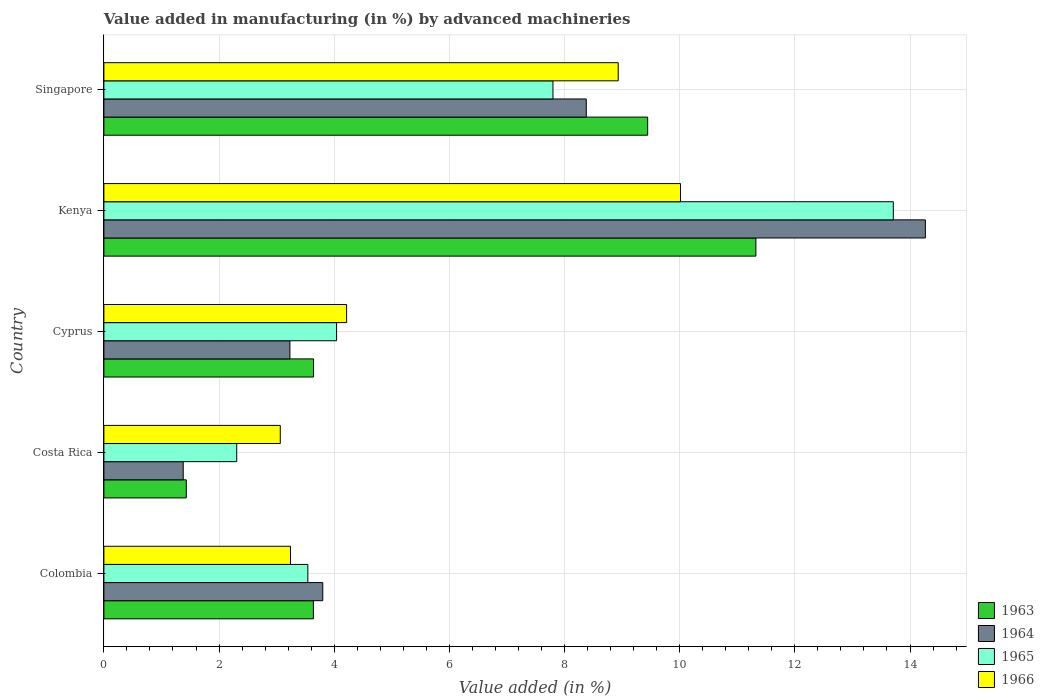How many groups of bars are there?
Ensure brevity in your answer.  5. Are the number of bars per tick equal to the number of legend labels?
Provide a succinct answer. Yes. Are the number of bars on each tick of the Y-axis equal?
Keep it short and to the point. Yes. How many bars are there on the 5th tick from the bottom?
Your response must be concise. 4. What is the label of the 3rd group of bars from the top?
Keep it short and to the point. Cyprus. In how many cases, is the number of bars for a given country not equal to the number of legend labels?
Provide a short and direct response. 0. What is the percentage of value added in manufacturing by advanced machineries in 1966 in Colombia?
Your answer should be very brief. 3.24. Across all countries, what is the maximum percentage of value added in manufacturing by advanced machineries in 1964?
Provide a succinct answer. 14.27. Across all countries, what is the minimum percentage of value added in manufacturing by advanced machineries in 1963?
Keep it short and to the point. 1.43. In which country was the percentage of value added in manufacturing by advanced machineries in 1964 maximum?
Provide a short and direct response. Kenya. What is the total percentage of value added in manufacturing by advanced machineries in 1965 in the graph?
Provide a succinct answer. 31.4. What is the difference between the percentage of value added in manufacturing by advanced machineries in 1965 in Colombia and that in Kenya?
Provide a short and direct response. -10.17. What is the difference between the percentage of value added in manufacturing by advanced machineries in 1965 in Cyprus and the percentage of value added in manufacturing by advanced machineries in 1966 in Costa Rica?
Your answer should be very brief. 0.98. What is the average percentage of value added in manufacturing by advanced machineries in 1963 per country?
Ensure brevity in your answer.  5.9. What is the difference between the percentage of value added in manufacturing by advanced machineries in 1966 and percentage of value added in manufacturing by advanced machineries in 1964 in Cyprus?
Ensure brevity in your answer.  0.98. In how many countries, is the percentage of value added in manufacturing by advanced machineries in 1965 greater than 10.4 %?
Ensure brevity in your answer.  1. What is the ratio of the percentage of value added in manufacturing by advanced machineries in 1963 in Costa Rica to that in Cyprus?
Keep it short and to the point. 0.39. Is the percentage of value added in manufacturing by advanced machineries in 1965 in Costa Rica less than that in Cyprus?
Provide a succinct answer. Yes. Is the difference between the percentage of value added in manufacturing by advanced machineries in 1966 in Cyprus and Kenya greater than the difference between the percentage of value added in manufacturing by advanced machineries in 1964 in Cyprus and Kenya?
Ensure brevity in your answer.  Yes. What is the difference between the highest and the second highest percentage of value added in manufacturing by advanced machineries in 1963?
Offer a very short reply. 1.88. What is the difference between the highest and the lowest percentage of value added in manufacturing by advanced machineries in 1963?
Ensure brevity in your answer.  9.89. In how many countries, is the percentage of value added in manufacturing by advanced machineries in 1964 greater than the average percentage of value added in manufacturing by advanced machineries in 1964 taken over all countries?
Make the answer very short. 2. What does the 1st bar from the top in Colombia represents?
Keep it short and to the point. 1966. What does the 1st bar from the bottom in Costa Rica represents?
Your answer should be very brief. 1963. Is it the case that in every country, the sum of the percentage of value added in manufacturing by advanced machineries in 1963 and percentage of value added in manufacturing by advanced machineries in 1964 is greater than the percentage of value added in manufacturing by advanced machineries in 1966?
Provide a short and direct response. No. How many bars are there?
Offer a very short reply. 20. Are the values on the major ticks of X-axis written in scientific E-notation?
Provide a short and direct response. No. Does the graph contain grids?
Offer a terse response. Yes. What is the title of the graph?
Provide a short and direct response. Value added in manufacturing (in %) by advanced machineries. What is the label or title of the X-axis?
Your answer should be very brief. Value added (in %). What is the label or title of the Y-axis?
Offer a terse response. Country. What is the Value added (in %) of 1963 in Colombia?
Provide a short and direct response. 3.64. What is the Value added (in %) of 1964 in Colombia?
Make the answer very short. 3.8. What is the Value added (in %) of 1965 in Colombia?
Your answer should be compact. 3.54. What is the Value added (in %) of 1966 in Colombia?
Offer a terse response. 3.24. What is the Value added (in %) in 1963 in Costa Rica?
Your answer should be very brief. 1.43. What is the Value added (in %) in 1964 in Costa Rica?
Offer a terse response. 1.38. What is the Value added (in %) in 1965 in Costa Rica?
Provide a short and direct response. 2.31. What is the Value added (in %) of 1966 in Costa Rica?
Provide a short and direct response. 3.06. What is the Value added (in %) of 1963 in Cyprus?
Offer a terse response. 3.64. What is the Value added (in %) of 1964 in Cyprus?
Offer a very short reply. 3.23. What is the Value added (in %) of 1965 in Cyprus?
Offer a terse response. 4.04. What is the Value added (in %) in 1966 in Cyprus?
Provide a short and direct response. 4.22. What is the Value added (in %) of 1963 in Kenya?
Offer a very short reply. 11.32. What is the Value added (in %) in 1964 in Kenya?
Offer a terse response. 14.27. What is the Value added (in %) of 1965 in Kenya?
Your response must be concise. 13.71. What is the Value added (in %) in 1966 in Kenya?
Ensure brevity in your answer.  10.01. What is the Value added (in %) in 1963 in Singapore?
Offer a terse response. 9.44. What is the Value added (in %) in 1964 in Singapore?
Your response must be concise. 8.38. What is the Value added (in %) in 1965 in Singapore?
Give a very brief answer. 7.8. What is the Value added (in %) in 1966 in Singapore?
Make the answer very short. 8.93. Across all countries, what is the maximum Value added (in %) of 1963?
Provide a succinct answer. 11.32. Across all countries, what is the maximum Value added (in %) of 1964?
Keep it short and to the point. 14.27. Across all countries, what is the maximum Value added (in %) of 1965?
Your response must be concise. 13.71. Across all countries, what is the maximum Value added (in %) in 1966?
Offer a very short reply. 10.01. Across all countries, what is the minimum Value added (in %) in 1963?
Make the answer very short. 1.43. Across all countries, what is the minimum Value added (in %) of 1964?
Offer a terse response. 1.38. Across all countries, what is the minimum Value added (in %) in 1965?
Provide a short and direct response. 2.31. Across all countries, what is the minimum Value added (in %) in 1966?
Make the answer very short. 3.06. What is the total Value added (in %) of 1963 in the graph?
Provide a succinct answer. 29.48. What is the total Value added (in %) of 1964 in the graph?
Ensure brevity in your answer.  31.05. What is the total Value added (in %) of 1965 in the graph?
Make the answer very short. 31.4. What is the total Value added (in %) in 1966 in the graph?
Your answer should be very brief. 29.47. What is the difference between the Value added (in %) in 1963 in Colombia and that in Costa Rica?
Offer a terse response. 2.21. What is the difference between the Value added (in %) in 1964 in Colombia and that in Costa Rica?
Make the answer very short. 2.42. What is the difference between the Value added (in %) of 1965 in Colombia and that in Costa Rica?
Your answer should be compact. 1.24. What is the difference between the Value added (in %) of 1966 in Colombia and that in Costa Rica?
Make the answer very short. 0.18. What is the difference between the Value added (in %) in 1963 in Colombia and that in Cyprus?
Your answer should be very brief. -0. What is the difference between the Value added (in %) in 1964 in Colombia and that in Cyprus?
Keep it short and to the point. 0.57. What is the difference between the Value added (in %) in 1965 in Colombia and that in Cyprus?
Your answer should be very brief. -0.5. What is the difference between the Value added (in %) of 1966 in Colombia and that in Cyprus?
Provide a succinct answer. -0.97. What is the difference between the Value added (in %) in 1963 in Colombia and that in Kenya?
Offer a very short reply. -7.69. What is the difference between the Value added (in %) of 1964 in Colombia and that in Kenya?
Your answer should be very brief. -10.47. What is the difference between the Value added (in %) of 1965 in Colombia and that in Kenya?
Your answer should be very brief. -10.17. What is the difference between the Value added (in %) in 1966 in Colombia and that in Kenya?
Keep it short and to the point. -6.77. What is the difference between the Value added (in %) in 1963 in Colombia and that in Singapore?
Your answer should be very brief. -5.81. What is the difference between the Value added (in %) of 1964 in Colombia and that in Singapore?
Make the answer very short. -4.58. What is the difference between the Value added (in %) in 1965 in Colombia and that in Singapore?
Provide a short and direct response. -4.26. What is the difference between the Value added (in %) of 1966 in Colombia and that in Singapore?
Provide a short and direct response. -5.69. What is the difference between the Value added (in %) of 1963 in Costa Rica and that in Cyprus?
Your response must be concise. -2.21. What is the difference between the Value added (in %) of 1964 in Costa Rica and that in Cyprus?
Your response must be concise. -1.85. What is the difference between the Value added (in %) of 1965 in Costa Rica and that in Cyprus?
Ensure brevity in your answer.  -1.73. What is the difference between the Value added (in %) in 1966 in Costa Rica and that in Cyprus?
Your answer should be compact. -1.15. What is the difference between the Value added (in %) of 1963 in Costa Rica and that in Kenya?
Ensure brevity in your answer.  -9.89. What is the difference between the Value added (in %) in 1964 in Costa Rica and that in Kenya?
Keep it short and to the point. -12.89. What is the difference between the Value added (in %) of 1965 in Costa Rica and that in Kenya?
Make the answer very short. -11.4. What is the difference between the Value added (in %) in 1966 in Costa Rica and that in Kenya?
Make the answer very short. -6.95. What is the difference between the Value added (in %) in 1963 in Costa Rica and that in Singapore?
Offer a very short reply. -8.01. What is the difference between the Value added (in %) of 1964 in Costa Rica and that in Singapore?
Provide a succinct answer. -7. What is the difference between the Value added (in %) in 1965 in Costa Rica and that in Singapore?
Offer a very short reply. -5.49. What is the difference between the Value added (in %) in 1966 in Costa Rica and that in Singapore?
Provide a succinct answer. -5.87. What is the difference between the Value added (in %) of 1963 in Cyprus and that in Kenya?
Provide a succinct answer. -7.68. What is the difference between the Value added (in %) in 1964 in Cyprus and that in Kenya?
Your answer should be very brief. -11.04. What is the difference between the Value added (in %) of 1965 in Cyprus and that in Kenya?
Keep it short and to the point. -9.67. What is the difference between the Value added (in %) of 1966 in Cyprus and that in Kenya?
Ensure brevity in your answer.  -5.8. What is the difference between the Value added (in %) in 1963 in Cyprus and that in Singapore?
Your answer should be very brief. -5.8. What is the difference between the Value added (in %) of 1964 in Cyprus and that in Singapore?
Offer a terse response. -5.15. What is the difference between the Value added (in %) of 1965 in Cyprus and that in Singapore?
Your response must be concise. -3.76. What is the difference between the Value added (in %) in 1966 in Cyprus and that in Singapore?
Provide a succinct answer. -4.72. What is the difference between the Value added (in %) of 1963 in Kenya and that in Singapore?
Your answer should be very brief. 1.88. What is the difference between the Value added (in %) in 1964 in Kenya and that in Singapore?
Your response must be concise. 5.89. What is the difference between the Value added (in %) in 1965 in Kenya and that in Singapore?
Your answer should be very brief. 5.91. What is the difference between the Value added (in %) in 1966 in Kenya and that in Singapore?
Give a very brief answer. 1.08. What is the difference between the Value added (in %) in 1963 in Colombia and the Value added (in %) in 1964 in Costa Rica?
Your answer should be compact. 2.26. What is the difference between the Value added (in %) in 1963 in Colombia and the Value added (in %) in 1965 in Costa Rica?
Your answer should be very brief. 1.33. What is the difference between the Value added (in %) in 1963 in Colombia and the Value added (in %) in 1966 in Costa Rica?
Make the answer very short. 0.57. What is the difference between the Value added (in %) of 1964 in Colombia and the Value added (in %) of 1965 in Costa Rica?
Give a very brief answer. 1.49. What is the difference between the Value added (in %) in 1964 in Colombia and the Value added (in %) in 1966 in Costa Rica?
Offer a very short reply. 0.74. What is the difference between the Value added (in %) in 1965 in Colombia and the Value added (in %) in 1966 in Costa Rica?
Keep it short and to the point. 0.48. What is the difference between the Value added (in %) of 1963 in Colombia and the Value added (in %) of 1964 in Cyprus?
Offer a very short reply. 0.41. What is the difference between the Value added (in %) in 1963 in Colombia and the Value added (in %) in 1965 in Cyprus?
Your answer should be compact. -0.4. What is the difference between the Value added (in %) of 1963 in Colombia and the Value added (in %) of 1966 in Cyprus?
Give a very brief answer. -0.58. What is the difference between the Value added (in %) in 1964 in Colombia and the Value added (in %) in 1965 in Cyprus?
Give a very brief answer. -0.24. What is the difference between the Value added (in %) in 1964 in Colombia and the Value added (in %) in 1966 in Cyprus?
Make the answer very short. -0.41. What is the difference between the Value added (in %) of 1965 in Colombia and the Value added (in %) of 1966 in Cyprus?
Ensure brevity in your answer.  -0.67. What is the difference between the Value added (in %) in 1963 in Colombia and the Value added (in %) in 1964 in Kenya?
Provide a short and direct response. -10.63. What is the difference between the Value added (in %) of 1963 in Colombia and the Value added (in %) of 1965 in Kenya?
Offer a terse response. -10.07. What is the difference between the Value added (in %) in 1963 in Colombia and the Value added (in %) in 1966 in Kenya?
Ensure brevity in your answer.  -6.38. What is the difference between the Value added (in %) of 1964 in Colombia and the Value added (in %) of 1965 in Kenya?
Your response must be concise. -9.91. What is the difference between the Value added (in %) of 1964 in Colombia and the Value added (in %) of 1966 in Kenya?
Offer a terse response. -6.21. What is the difference between the Value added (in %) in 1965 in Colombia and the Value added (in %) in 1966 in Kenya?
Make the answer very short. -6.47. What is the difference between the Value added (in %) of 1963 in Colombia and the Value added (in %) of 1964 in Singapore?
Offer a very short reply. -4.74. What is the difference between the Value added (in %) of 1963 in Colombia and the Value added (in %) of 1965 in Singapore?
Keep it short and to the point. -4.16. What is the difference between the Value added (in %) in 1963 in Colombia and the Value added (in %) in 1966 in Singapore?
Offer a very short reply. -5.29. What is the difference between the Value added (in %) of 1964 in Colombia and the Value added (in %) of 1965 in Singapore?
Your answer should be compact. -4. What is the difference between the Value added (in %) in 1964 in Colombia and the Value added (in %) in 1966 in Singapore?
Your answer should be compact. -5.13. What is the difference between the Value added (in %) in 1965 in Colombia and the Value added (in %) in 1966 in Singapore?
Make the answer very short. -5.39. What is the difference between the Value added (in %) of 1963 in Costa Rica and the Value added (in %) of 1964 in Cyprus?
Provide a short and direct response. -1.8. What is the difference between the Value added (in %) in 1963 in Costa Rica and the Value added (in %) in 1965 in Cyprus?
Provide a succinct answer. -2.61. What is the difference between the Value added (in %) of 1963 in Costa Rica and the Value added (in %) of 1966 in Cyprus?
Keep it short and to the point. -2.78. What is the difference between the Value added (in %) in 1964 in Costa Rica and the Value added (in %) in 1965 in Cyprus?
Ensure brevity in your answer.  -2.66. What is the difference between the Value added (in %) of 1964 in Costa Rica and the Value added (in %) of 1966 in Cyprus?
Offer a terse response. -2.84. What is the difference between the Value added (in %) of 1965 in Costa Rica and the Value added (in %) of 1966 in Cyprus?
Offer a terse response. -1.91. What is the difference between the Value added (in %) in 1963 in Costa Rica and the Value added (in %) in 1964 in Kenya?
Your answer should be very brief. -12.84. What is the difference between the Value added (in %) of 1963 in Costa Rica and the Value added (in %) of 1965 in Kenya?
Provide a short and direct response. -12.28. What is the difference between the Value added (in %) in 1963 in Costa Rica and the Value added (in %) in 1966 in Kenya?
Provide a short and direct response. -8.58. What is the difference between the Value added (in %) in 1964 in Costa Rica and the Value added (in %) in 1965 in Kenya?
Your answer should be compact. -12.33. What is the difference between the Value added (in %) in 1964 in Costa Rica and the Value added (in %) in 1966 in Kenya?
Provide a short and direct response. -8.64. What is the difference between the Value added (in %) in 1965 in Costa Rica and the Value added (in %) in 1966 in Kenya?
Your answer should be compact. -7.71. What is the difference between the Value added (in %) in 1963 in Costa Rica and the Value added (in %) in 1964 in Singapore?
Provide a succinct answer. -6.95. What is the difference between the Value added (in %) in 1963 in Costa Rica and the Value added (in %) in 1965 in Singapore?
Give a very brief answer. -6.37. What is the difference between the Value added (in %) in 1963 in Costa Rica and the Value added (in %) in 1966 in Singapore?
Offer a terse response. -7.5. What is the difference between the Value added (in %) of 1964 in Costa Rica and the Value added (in %) of 1965 in Singapore?
Ensure brevity in your answer.  -6.42. What is the difference between the Value added (in %) in 1964 in Costa Rica and the Value added (in %) in 1966 in Singapore?
Keep it short and to the point. -7.55. What is the difference between the Value added (in %) in 1965 in Costa Rica and the Value added (in %) in 1966 in Singapore?
Provide a short and direct response. -6.63. What is the difference between the Value added (in %) of 1963 in Cyprus and the Value added (in %) of 1964 in Kenya?
Provide a short and direct response. -10.63. What is the difference between the Value added (in %) of 1963 in Cyprus and the Value added (in %) of 1965 in Kenya?
Offer a very short reply. -10.07. What is the difference between the Value added (in %) of 1963 in Cyprus and the Value added (in %) of 1966 in Kenya?
Your response must be concise. -6.37. What is the difference between the Value added (in %) of 1964 in Cyprus and the Value added (in %) of 1965 in Kenya?
Your answer should be very brief. -10.48. What is the difference between the Value added (in %) of 1964 in Cyprus and the Value added (in %) of 1966 in Kenya?
Ensure brevity in your answer.  -6.78. What is the difference between the Value added (in %) in 1965 in Cyprus and the Value added (in %) in 1966 in Kenya?
Your answer should be compact. -5.97. What is the difference between the Value added (in %) of 1963 in Cyprus and the Value added (in %) of 1964 in Singapore?
Provide a short and direct response. -4.74. What is the difference between the Value added (in %) in 1963 in Cyprus and the Value added (in %) in 1965 in Singapore?
Provide a succinct answer. -4.16. What is the difference between the Value added (in %) in 1963 in Cyprus and the Value added (in %) in 1966 in Singapore?
Your answer should be very brief. -5.29. What is the difference between the Value added (in %) of 1964 in Cyprus and the Value added (in %) of 1965 in Singapore?
Your response must be concise. -4.57. What is the difference between the Value added (in %) in 1964 in Cyprus and the Value added (in %) in 1966 in Singapore?
Provide a short and direct response. -5.7. What is the difference between the Value added (in %) in 1965 in Cyprus and the Value added (in %) in 1966 in Singapore?
Your answer should be compact. -4.89. What is the difference between the Value added (in %) in 1963 in Kenya and the Value added (in %) in 1964 in Singapore?
Give a very brief answer. 2.95. What is the difference between the Value added (in %) of 1963 in Kenya and the Value added (in %) of 1965 in Singapore?
Provide a short and direct response. 3.52. What is the difference between the Value added (in %) in 1963 in Kenya and the Value added (in %) in 1966 in Singapore?
Your response must be concise. 2.39. What is the difference between the Value added (in %) in 1964 in Kenya and the Value added (in %) in 1965 in Singapore?
Provide a short and direct response. 6.47. What is the difference between the Value added (in %) of 1964 in Kenya and the Value added (in %) of 1966 in Singapore?
Provide a succinct answer. 5.33. What is the difference between the Value added (in %) of 1965 in Kenya and the Value added (in %) of 1966 in Singapore?
Your answer should be very brief. 4.78. What is the average Value added (in %) in 1963 per country?
Offer a terse response. 5.9. What is the average Value added (in %) of 1964 per country?
Keep it short and to the point. 6.21. What is the average Value added (in %) of 1965 per country?
Offer a very short reply. 6.28. What is the average Value added (in %) of 1966 per country?
Your answer should be very brief. 5.89. What is the difference between the Value added (in %) in 1963 and Value added (in %) in 1964 in Colombia?
Make the answer very short. -0.16. What is the difference between the Value added (in %) of 1963 and Value added (in %) of 1965 in Colombia?
Make the answer very short. 0.1. What is the difference between the Value added (in %) of 1963 and Value added (in %) of 1966 in Colombia?
Offer a very short reply. 0.4. What is the difference between the Value added (in %) of 1964 and Value added (in %) of 1965 in Colombia?
Offer a very short reply. 0.26. What is the difference between the Value added (in %) in 1964 and Value added (in %) in 1966 in Colombia?
Your answer should be very brief. 0.56. What is the difference between the Value added (in %) in 1965 and Value added (in %) in 1966 in Colombia?
Provide a short and direct response. 0.3. What is the difference between the Value added (in %) of 1963 and Value added (in %) of 1964 in Costa Rica?
Offer a terse response. 0.05. What is the difference between the Value added (in %) of 1963 and Value added (in %) of 1965 in Costa Rica?
Offer a terse response. -0.88. What is the difference between the Value added (in %) in 1963 and Value added (in %) in 1966 in Costa Rica?
Your response must be concise. -1.63. What is the difference between the Value added (in %) of 1964 and Value added (in %) of 1965 in Costa Rica?
Make the answer very short. -0.93. What is the difference between the Value added (in %) of 1964 and Value added (in %) of 1966 in Costa Rica?
Make the answer very short. -1.69. What is the difference between the Value added (in %) of 1965 and Value added (in %) of 1966 in Costa Rica?
Your answer should be compact. -0.76. What is the difference between the Value added (in %) of 1963 and Value added (in %) of 1964 in Cyprus?
Your answer should be very brief. 0.41. What is the difference between the Value added (in %) in 1963 and Value added (in %) in 1965 in Cyprus?
Provide a succinct answer. -0.4. What is the difference between the Value added (in %) of 1963 and Value added (in %) of 1966 in Cyprus?
Provide a short and direct response. -0.57. What is the difference between the Value added (in %) of 1964 and Value added (in %) of 1965 in Cyprus?
Give a very brief answer. -0.81. What is the difference between the Value added (in %) of 1964 and Value added (in %) of 1966 in Cyprus?
Offer a very short reply. -0.98. What is the difference between the Value added (in %) of 1965 and Value added (in %) of 1966 in Cyprus?
Your response must be concise. -0.17. What is the difference between the Value added (in %) of 1963 and Value added (in %) of 1964 in Kenya?
Your answer should be compact. -2.94. What is the difference between the Value added (in %) in 1963 and Value added (in %) in 1965 in Kenya?
Your response must be concise. -2.39. What is the difference between the Value added (in %) of 1963 and Value added (in %) of 1966 in Kenya?
Offer a very short reply. 1.31. What is the difference between the Value added (in %) in 1964 and Value added (in %) in 1965 in Kenya?
Make the answer very short. 0.56. What is the difference between the Value added (in %) of 1964 and Value added (in %) of 1966 in Kenya?
Provide a short and direct response. 4.25. What is the difference between the Value added (in %) in 1965 and Value added (in %) in 1966 in Kenya?
Make the answer very short. 3.7. What is the difference between the Value added (in %) in 1963 and Value added (in %) in 1964 in Singapore?
Ensure brevity in your answer.  1.07. What is the difference between the Value added (in %) in 1963 and Value added (in %) in 1965 in Singapore?
Provide a short and direct response. 1.64. What is the difference between the Value added (in %) in 1963 and Value added (in %) in 1966 in Singapore?
Provide a short and direct response. 0.51. What is the difference between the Value added (in %) of 1964 and Value added (in %) of 1965 in Singapore?
Provide a succinct answer. 0.58. What is the difference between the Value added (in %) of 1964 and Value added (in %) of 1966 in Singapore?
Give a very brief answer. -0.55. What is the difference between the Value added (in %) in 1965 and Value added (in %) in 1966 in Singapore?
Offer a very short reply. -1.13. What is the ratio of the Value added (in %) in 1963 in Colombia to that in Costa Rica?
Make the answer very short. 2.54. What is the ratio of the Value added (in %) of 1964 in Colombia to that in Costa Rica?
Offer a terse response. 2.76. What is the ratio of the Value added (in %) of 1965 in Colombia to that in Costa Rica?
Ensure brevity in your answer.  1.54. What is the ratio of the Value added (in %) of 1966 in Colombia to that in Costa Rica?
Keep it short and to the point. 1.06. What is the ratio of the Value added (in %) of 1964 in Colombia to that in Cyprus?
Your answer should be very brief. 1.18. What is the ratio of the Value added (in %) in 1965 in Colombia to that in Cyprus?
Ensure brevity in your answer.  0.88. What is the ratio of the Value added (in %) in 1966 in Colombia to that in Cyprus?
Provide a short and direct response. 0.77. What is the ratio of the Value added (in %) in 1963 in Colombia to that in Kenya?
Keep it short and to the point. 0.32. What is the ratio of the Value added (in %) of 1964 in Colombia to that in Kenya?
Your response must be concise. 0.27. What is the ratio of the Value added (in %) in 1965 in Colombia to that in Kenya?
Give a very brief answer. 0.26. What is the ratio of the Value added (in %) in 1966 in Colombia to that in Kenya?
Keep it short and to the point. 0.32. What is the ratio of the Value added (in %) of 1963 in Colombia to that in Singapore?
Make the answer very short. 0.39. What is the ratio of the Value added (in %) in 1964 in Colombia to that in Singapore?
Provide a short and direct response. 0.45. What is the ratio of the Value added (in %) of 1965 in Colombia to that in Singapore?
Provide a short and direct response. 0.45. What is the ratio of the Value added (in %) in 1966 in Colombia to that in Singapore?
Provide a succinct answer. 0.36. What is the ratio of the Value added (in %) in 1963 in Costa Rica to that in Cyprus?
Give a very brief answer. 0.39. What is the ratio of the Value added (in %) in 1964 in Costa Rica to that in Cyprus?
Keep it short and to the point. 0.43. What is the ratio of the Value added (in %) of 1965 in Costa Rica to that in Cyprus?
Provide a short and direct response. 0.57. What is the ratio of the Value added (in %) in 1966 in Costa Rica to that in Cyprus?
Offer a terse response. 0.73. What is the ratio of the Value added (in %) in 1963 in Costa Rica to that in Kenya?
Your answer should be compact. 0.13. What is the ratio of the Value added (in %) in 1964 in Costa Rica to that in Kenya?
Give a very brief answer. 0.1. What is the ratio of the Value added (in %) of 1965 in Costa Rica to that in Kenya?
Ensure brevity in your answer.  0.17. What is the ratio of the Value added (in %) of 1966 in Costa Rica to that in Kenya?
Your answer should be very brief. 0.31. What is the ratio of the Value added (in %) in 1963 in Costa Rica to that in Singapore?
Your answer should be compact. 0.15. What is the ratio of the Value added (in %) in 1964 in Costa Rica to that in Singapore?
Offer a very short reply. 0.16. What is the ratio of the Value added (in %) in 1965 in Costa Rica to that in Singapore?
Offer a very short reply. 0.3. What is the ratio of the Value added (in %) of 1966 in Costa Rica to that in Singapore?
Offer a very short reply. 0.34. What is the ratio of the Value added (in %) in 1963 in Cyprus to that in Kenya?
Your answer should be very brief. 0.32. What is the ratio of the Value added (in %) in 1964 in Cyprus to that in Kenya?
Keep it short and to the point. 0.23. What is the ratio of the Value added (in %) in 1965 in Cyprus to that in Kenya?
Keep it short and to the point. 0.29. What is the ratio of the Value added (in %) in 1966 in Cyprus to that in Kenya?
Make the answer very short. 0.42. What is the ratio of the Value added (in %) of 1963 in Cyprus to that in Singapore?
Your answer should be very brief. 0.39. What is the ratio of the Value added (in %) in 1964 in Cyprus to that in Singapore?
Ensure brevity in your answer.  0.39. What is the ratio of the Value added (in %) of 1965 in Cyprus to that in Singapore?
Your answer should be very brief. 0.52. What is the ratio of the Value added (in %) of 1966 in Cyprus to that in Singapore?
Provide a short and direct response. 0.47. What is the ratio of the Value added (in %) of 1963 in Kenya to that in Singapore?
Offer a very short reply. 1.2. What is the ratio of the Value added (in %) in 1964 in Kenya to that in Singapore?
Provide a succinct answer. 1.7. What is the ratio of the Value added (in %) of 1965 in Kenya to that in Singapore?
Your response must be concise. 1.76. What is the ratio of the Value added (in %) of 1966 in Kenya to that in Singapore?
Provide a succinct answer. 1.12. What is the difference between the highest and the second highest Value added (in %) of 1963?
Your answer should be very brief. 1.88. What is the difference between the highest and the second highest Value added (in %) in 1964?
Offer a very short reply. 5.89. What is the difference between the highest and the second highest Value added (in %) of 1965?
Make the answer very short. 5.91. What is the difference between the highest and the second highest Value added (in %) of 1966?
Offer a terse response. 1.08. What is the difference between the highest and the lowest Value added (in %) of 1963?
Ensure brevity in your answer.  9.89. What is the difference between the highest and the lowest Value added (in %) in 1964?
Offer a terse response. 12.89. What is the difference between the highest and the lowest Value added (in %) in 1965?
Provide a succinct answer. 11.4. What is the difference between the highest and the lowest Value added (in %) in 1966?
Make the answer very short. 6.95. 